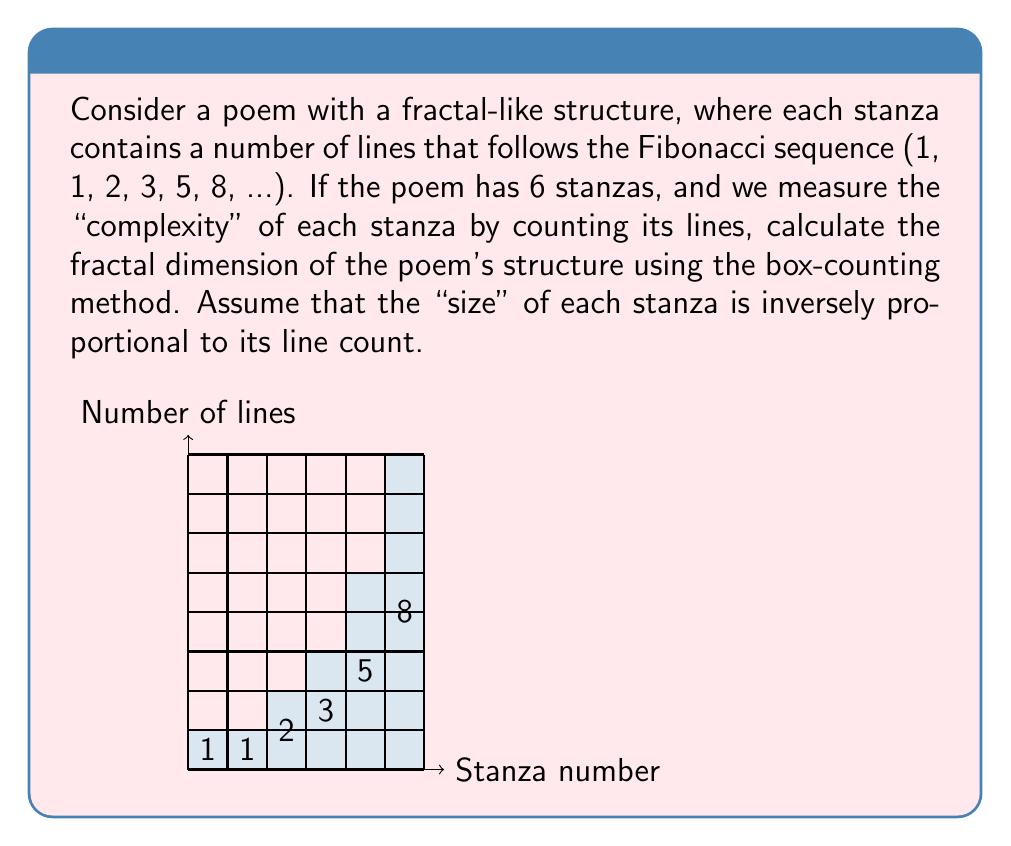Help me with this question. To calculate the fractal dimension using the box-counting method, we need to follow these steps:

1) First, let's identify our "boxes" and their sizes. Each stanza is a box, and its size is inversely proportional to its line count. So, the sizes are:

   $$s_1 = 1, s_2 = 1, s_3 = \frac{1}{2}, s_4 = \frac{1}{3}, s_5 = \frac{1}{5}, s_6 = \frac{1}{8}$$

2) Now, we need to count how many boxes (stanzas) are larger than or equal to each size. Let's call this count N(s):

   $$N(1) = 2, N(\frac{1}{2}) = 3, N(\frac{1}{3}) = 4, N(\frac{1}{5}) = 5, N(\frac{1}{8}) = 6$$

3) The fractal dimension D is given by the slope of the log-log plot of N(s) vs 1/s. We can calculate this using the formula:

   $$D = \lim_{s \to 0} \frac{\log N(s)}{\log(1/s)}$$

4) We can approximate this by calculating the slope between the smallest and largest s:

   $$D \approx \frac{\log N(1/8) - \log N(1)}{\log(8) - \log(1)} = \frac{\log 6 - \log 2}{\log 8 - \log 1} = \frac{\log 3}{\log 8}$$

5) Calculating this:

   $$D \approx \frac{\log 3}{\log 8} \approx 0.6309$$

This fractal dimension between 0 and 1 indicates that the poem's structure has some fractal-like properties, but is not as complex as a full 2D fractal.
Answer: $D \approx 0.6309$ 